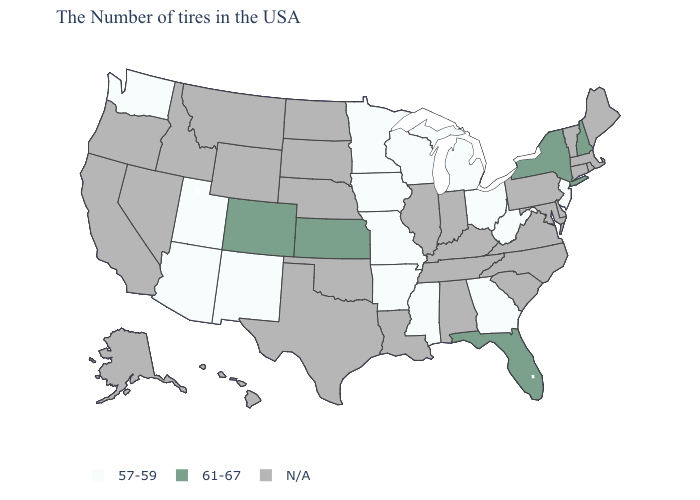Is the legend a continuous bar?
Short answer required. No. What is the value of North Carolina?
Answer briefly. N/A. Which states have the lowest value in the West?
Concise answer only. New Mexico, Utah, Arizona, Washington. Does Arkansas have the highest value in the South?
Keep it brief. No. Name the states that have a value in the range 61-67?
Answer briefly. New Hampshire, New York, Florida, Kansas, Colorado. What is the value of Oklahoma?
Be succinct. N/A. What is the lowest value in the USA?
Give a very brief answer. 57-59. Does Kansas have the highest value in the MidWest?
Give a very brief answer. Yes. Name the states that have a value in the range 61-67?
Concise answer only. New Hampshire, New York, Florida, Kansas, Colorado. Name the states that have a value in the range 57-59?
Keep it brief. New Jersey, West Virginia, Ohio, Georgia, Michigan, Wisconsin, Mississippi, Missouri, Arkansas, Minnesota, Iowa, New Mexico, Utah, Arizona, Washington. Name the states that have a value in the range 61-67?
Quick response, please. New Hampshire, New York, Florida, Kansas, Colorado. What is the value of Montana?
Keep it brief. N/A. 